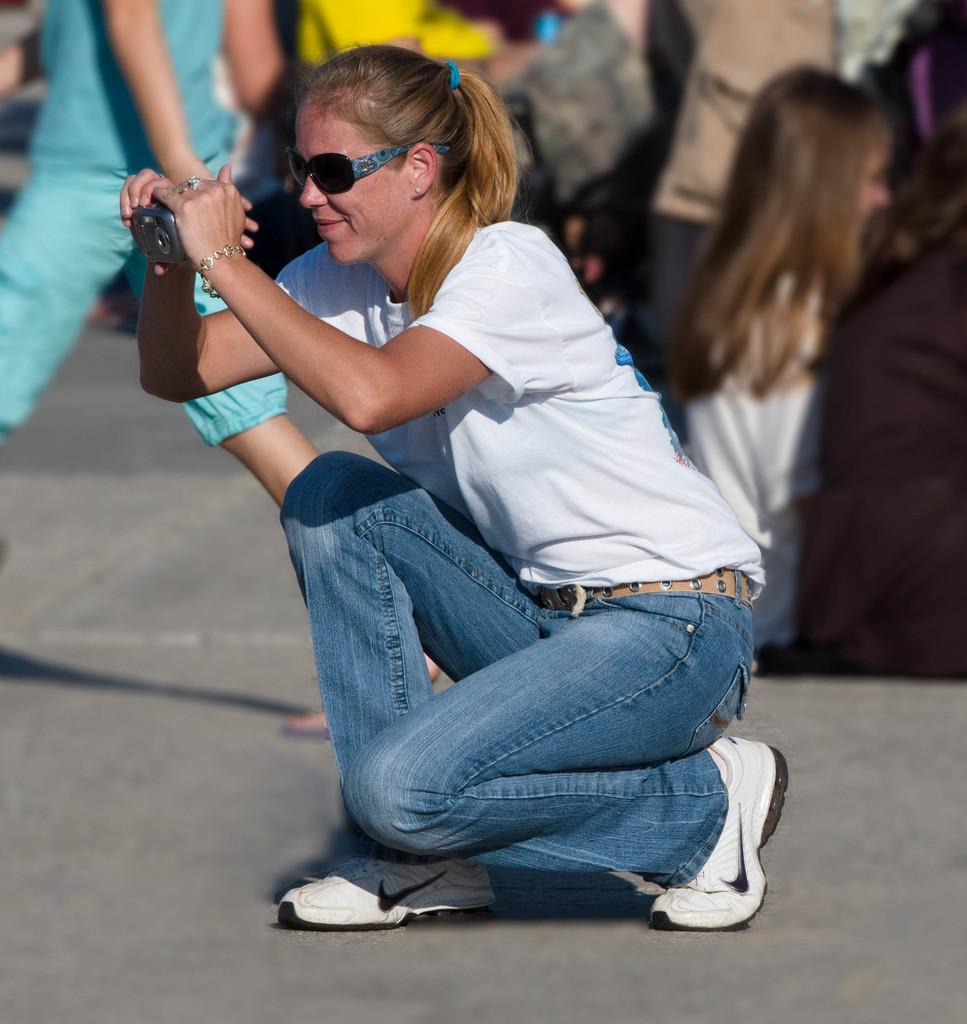How many people are in the image? There are people in the image, but the exact number is not specified. What is the woman wearing in the image? The woman is wearing a white t-shirt and white shoes in the image. What is the woman holding in her hand? The woman is holding a camera in her hand in the image. Can you tell me how many goldfish are swimming in the woman's white t-shirt? There are no goldfish present in the image, and they are not swimming in the woman's white t-shirt. 